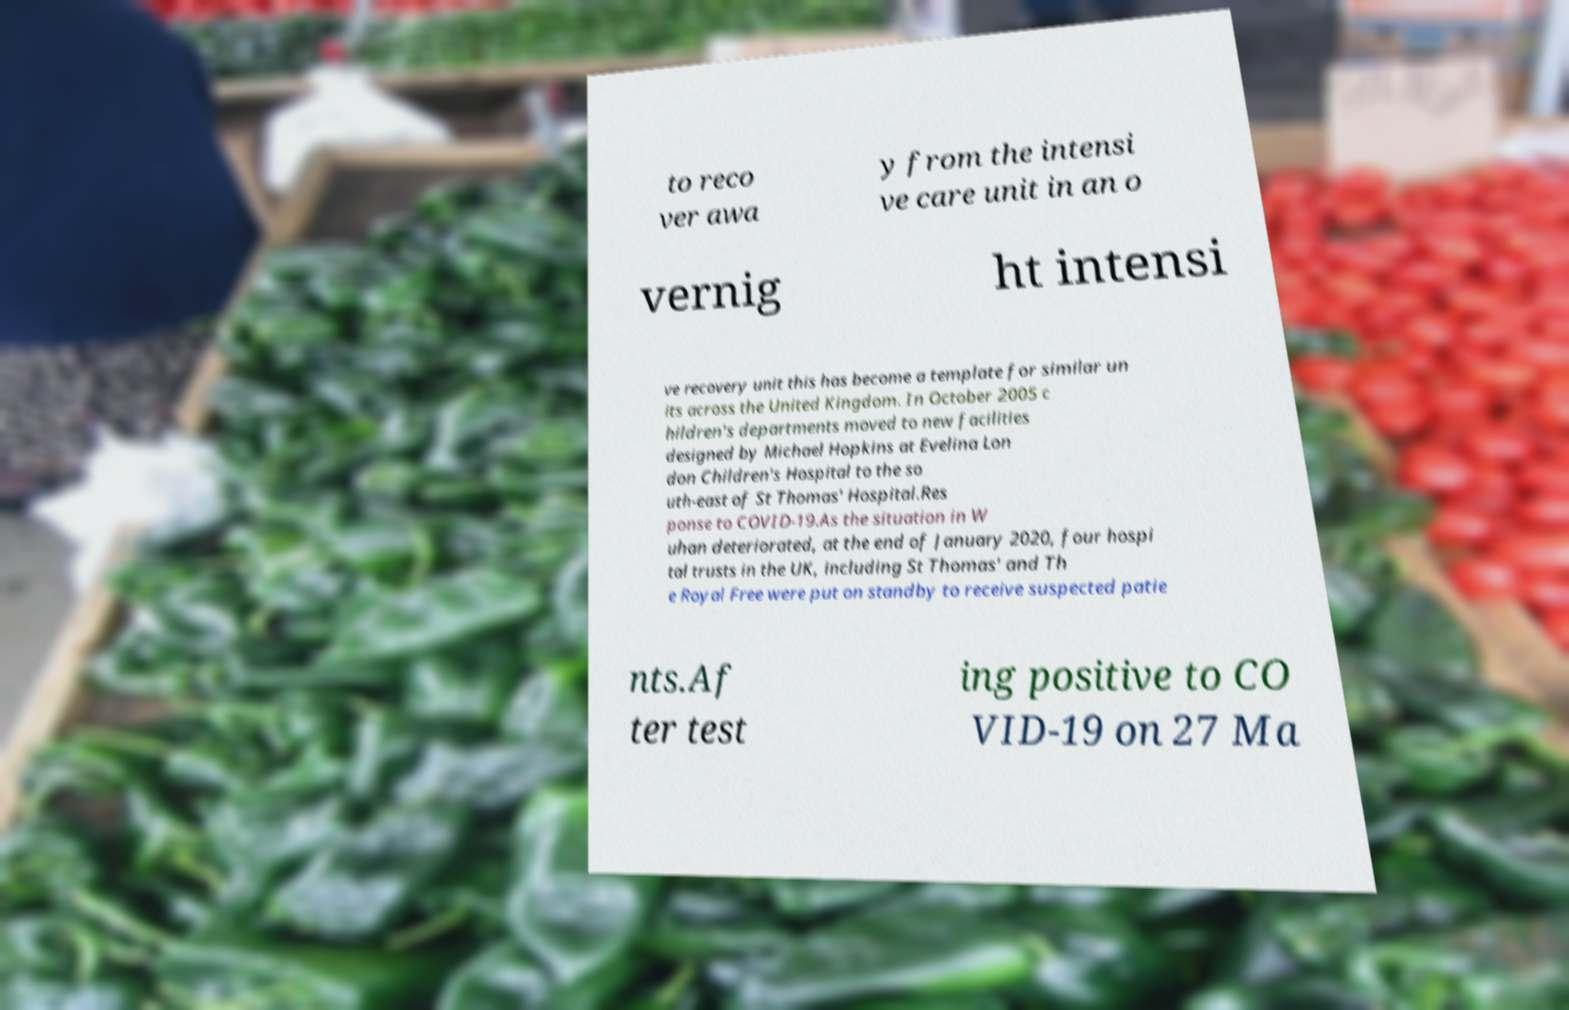What messages or text are displayed in this image? I need them in a readable, typed format. to reco ver awa y from the intensi ve care unit in an o vernig ht intensi ve recovery unit this has become a template for similar un its across the United Kingdom. In October 2005 c hildren's departments moved to new facilities designed by Michael Hopkins at Evelina Lon don Children's Hospital to the so uth-east of St Thomas' Hospital.Res ponse to COVID-19.As the situation in W uhan deteriorated, at the end of January 2020, four hospi tal trusts in the UK, including St Thomas' and Th e Royal Free were put on standby to receive suspected patie nts.Af ter test ing positive to CO VID-19 on 27 Ma 